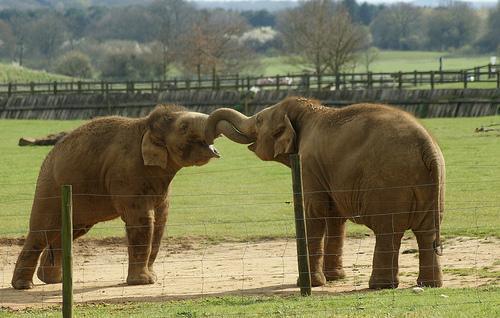How many elephants are pictured?
Give a very brief answer. 2. 